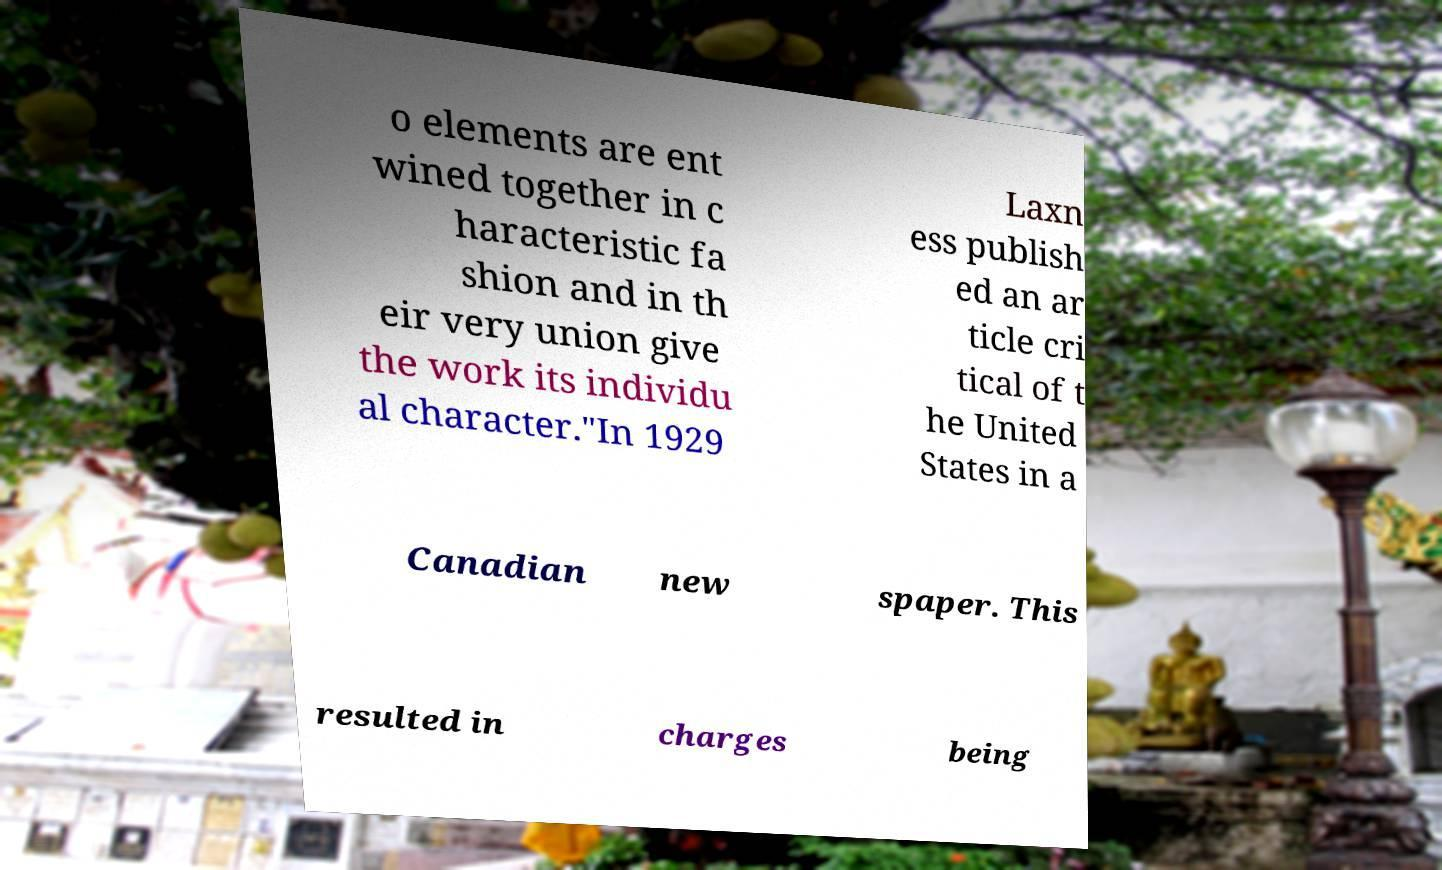For documentation purposes, I need the text within this image transcribed. Could you provide that? o elements are ent wined together in c haracteristic fa shion and in th eir very union give the work its individu al character."In 1929 Laxn ess publish ed an ar ticle cri tical of t he United States in a Canadian new spaper. This resulted in charges being 